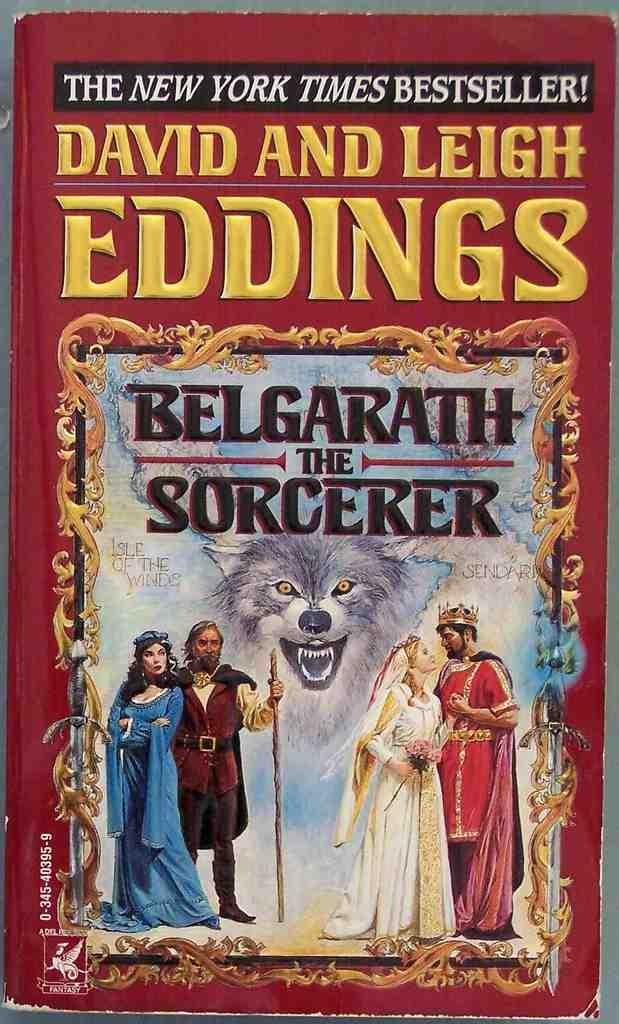<image>
Relay a brief, clear account of the picture shown. Belgrath the Sorcerer, the book, has tattered edges. 